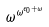Convert formula to latex. <formula><loc_0><loc_0><loc_500><loc_500>\omega ^ { \omega ^ { \epsilon _ { 0 } + \omega } }</formula> 